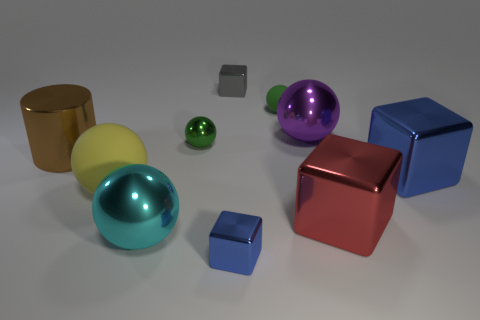Subtract all purple balls. How many balls are left? 4 Subtract all gray blocks. How many blocks are left? 3 Subtract all blocks. How many objects are left? 6 Subtract 0 blue balls. How many objects are left? 10 Subtract 4 spheres. How many spheres are left? 1 Subtract all brown spheres. Subtract all gray cylinders. How many spheres are left? 5 Subtract all yellow blocks. How many green spheres are left? 2 Subtract all tiny green spheres. Subtract all big purple metallic things. How many objects are left? 7 Add 9 small green metallic balls. How many small green metallic balls are left? 10 Add 8 small gray matte cylinders. How many small gray matte cylinders exist? 8 